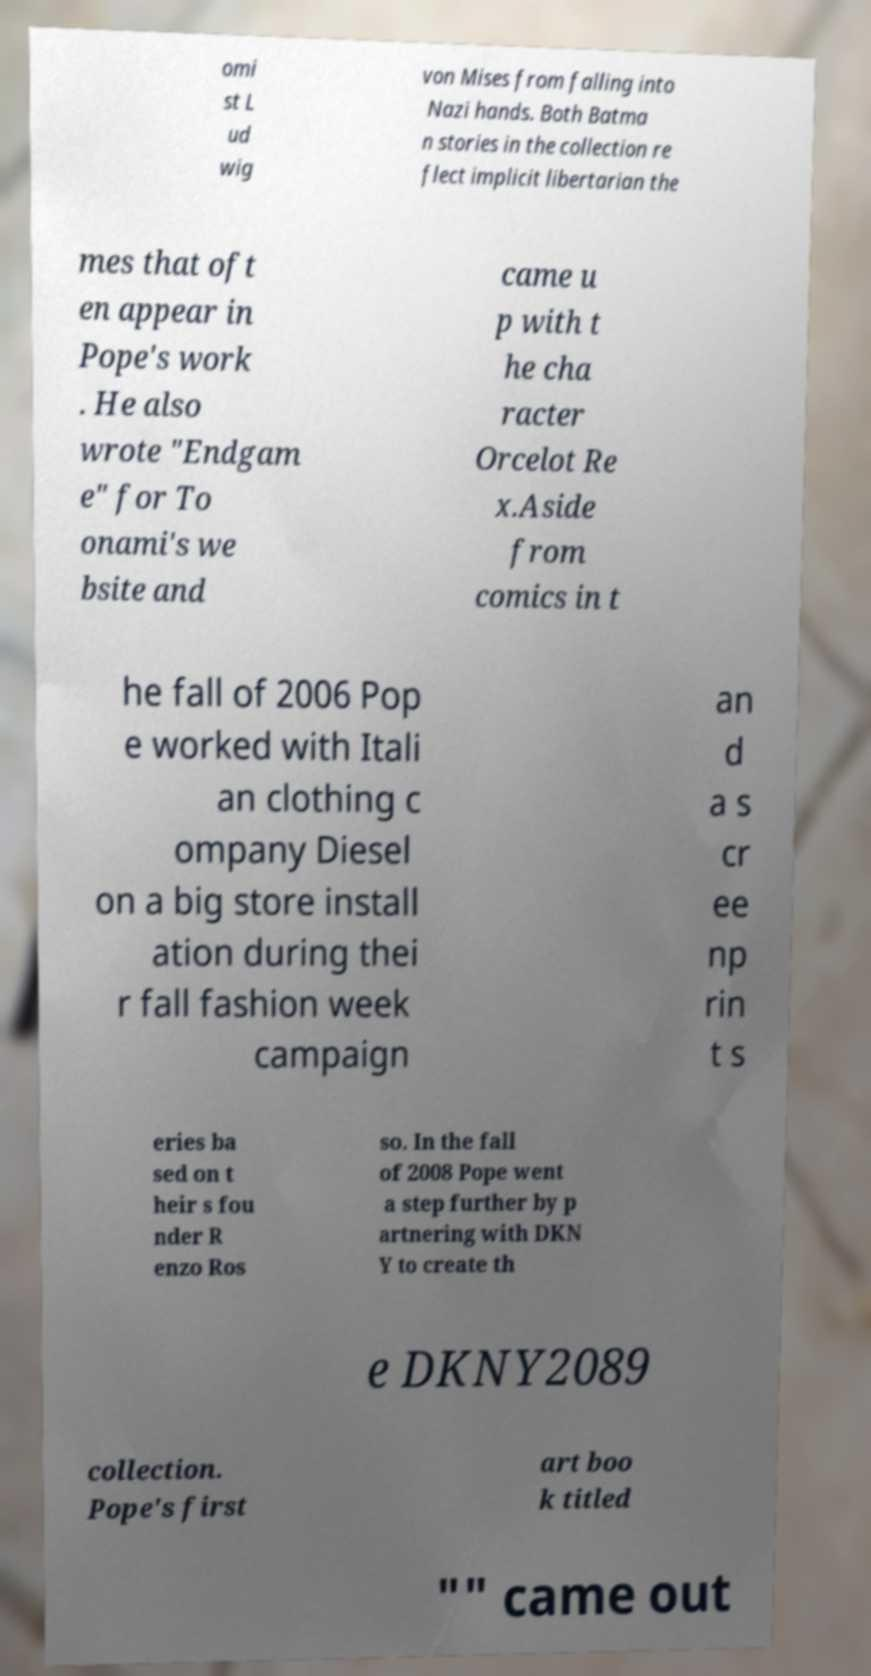Please read and relay the text visible in this image. What does it say? omi st L ud wig von Mises from falling into Nazi hands. Both Batma n stories in the collection re flect implicit libertarian the mes that oft en appear in Pope's work . He also wrote "Endgam e" for To onami's we bsite and came u p with t he cha racter Orcelot Re x.Aside from comics in t he fall of 2006 Pop e worked with Itali an clothing c ompany Diesel on a big store install ation during thei r fall fashion week campaign an d a s cr ee np rin t s eries ba sed on t heir s fou nder R enzo Ros so. In the fall of 2008 Pope went a step further by p artnering with DKN Y to create th e DKNY2089 collection. Pope's first art boo k titled "" came out 